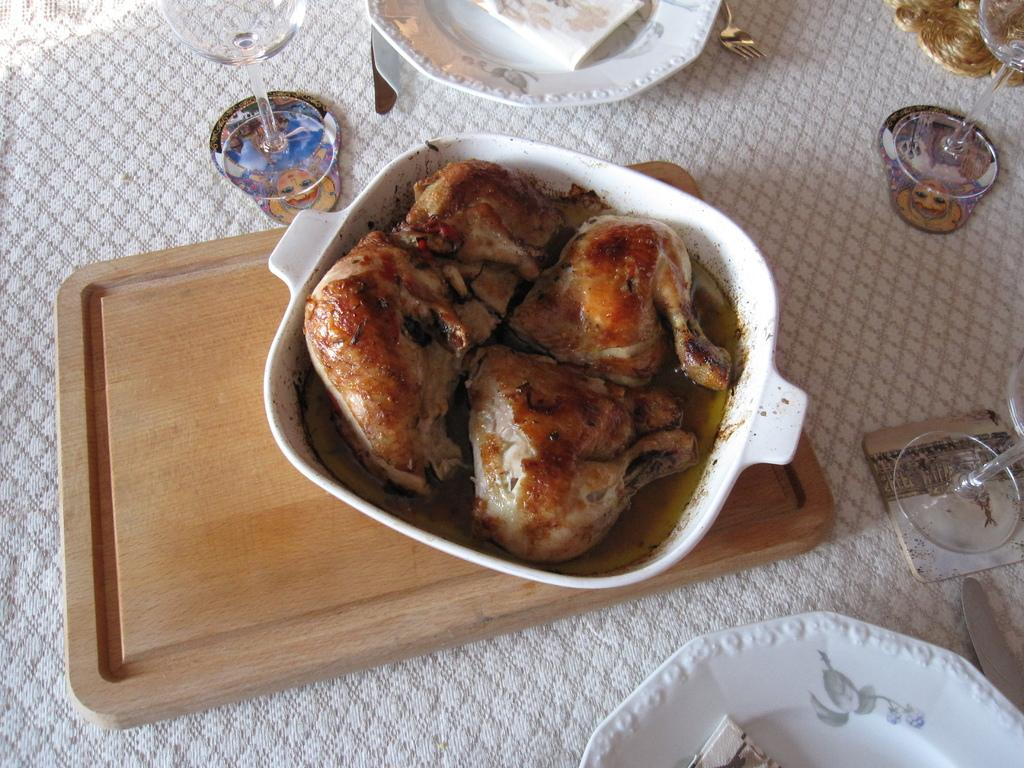What is the main object in the image? There is a cloth in the image. What is placed on the cloth? There is a wooden object, plates, glasses, a fork, a knife, and a bowl on the cloth. What is inside the bowl? There are food items in the bowl. What flavor of lip balm is visible in the image? There is no lip balm present in the image. Can you describe the burn marks on the wooden object in the image? There are no burn marks visible on the wooden object in the image. 